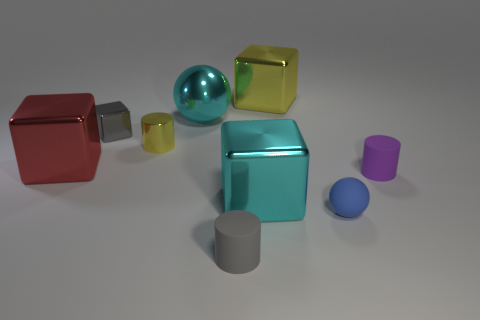Are there more tiny gray matte things that are on the left side of the gray cylinder than big shiny balls to the left of the small cube?
Provide a short and direct response. No. How many other things are there of the same size as the cyan sphere?
Provide a short and direct response. 3. Do the large block behind the large sphere and the metallic cylinder have the same color?
Give a very brief answer. Yes. Are there more tiny blue rubber objects to the left of the blue sphere than small purple rubber objects?
Make the answer very short. No. Are there any other things of the same color as the shiny ball?
Offer a terse response. Yes. The big cyan thing that is in front of the matte cylinder to the right of the big yellow metal block is what shape?
Provide a succinct answer. Cube. Are there more large yellow blocks than cubes?
Provide a succinct answer. No. How many large shiny objects are behind the tiny yellow cylinder and to the right of the gray cylinder?
Offer a terse response. 1. How many large red objects are behind the tiny matte cylinder right of the small gray matte thing?
Your response must be concise. 1. What number of objects are tiny matte cylinders that are right of the tiny ball or blocks to the left of the tiny yellow cylinder?
Your answer should be very brief. 3. 